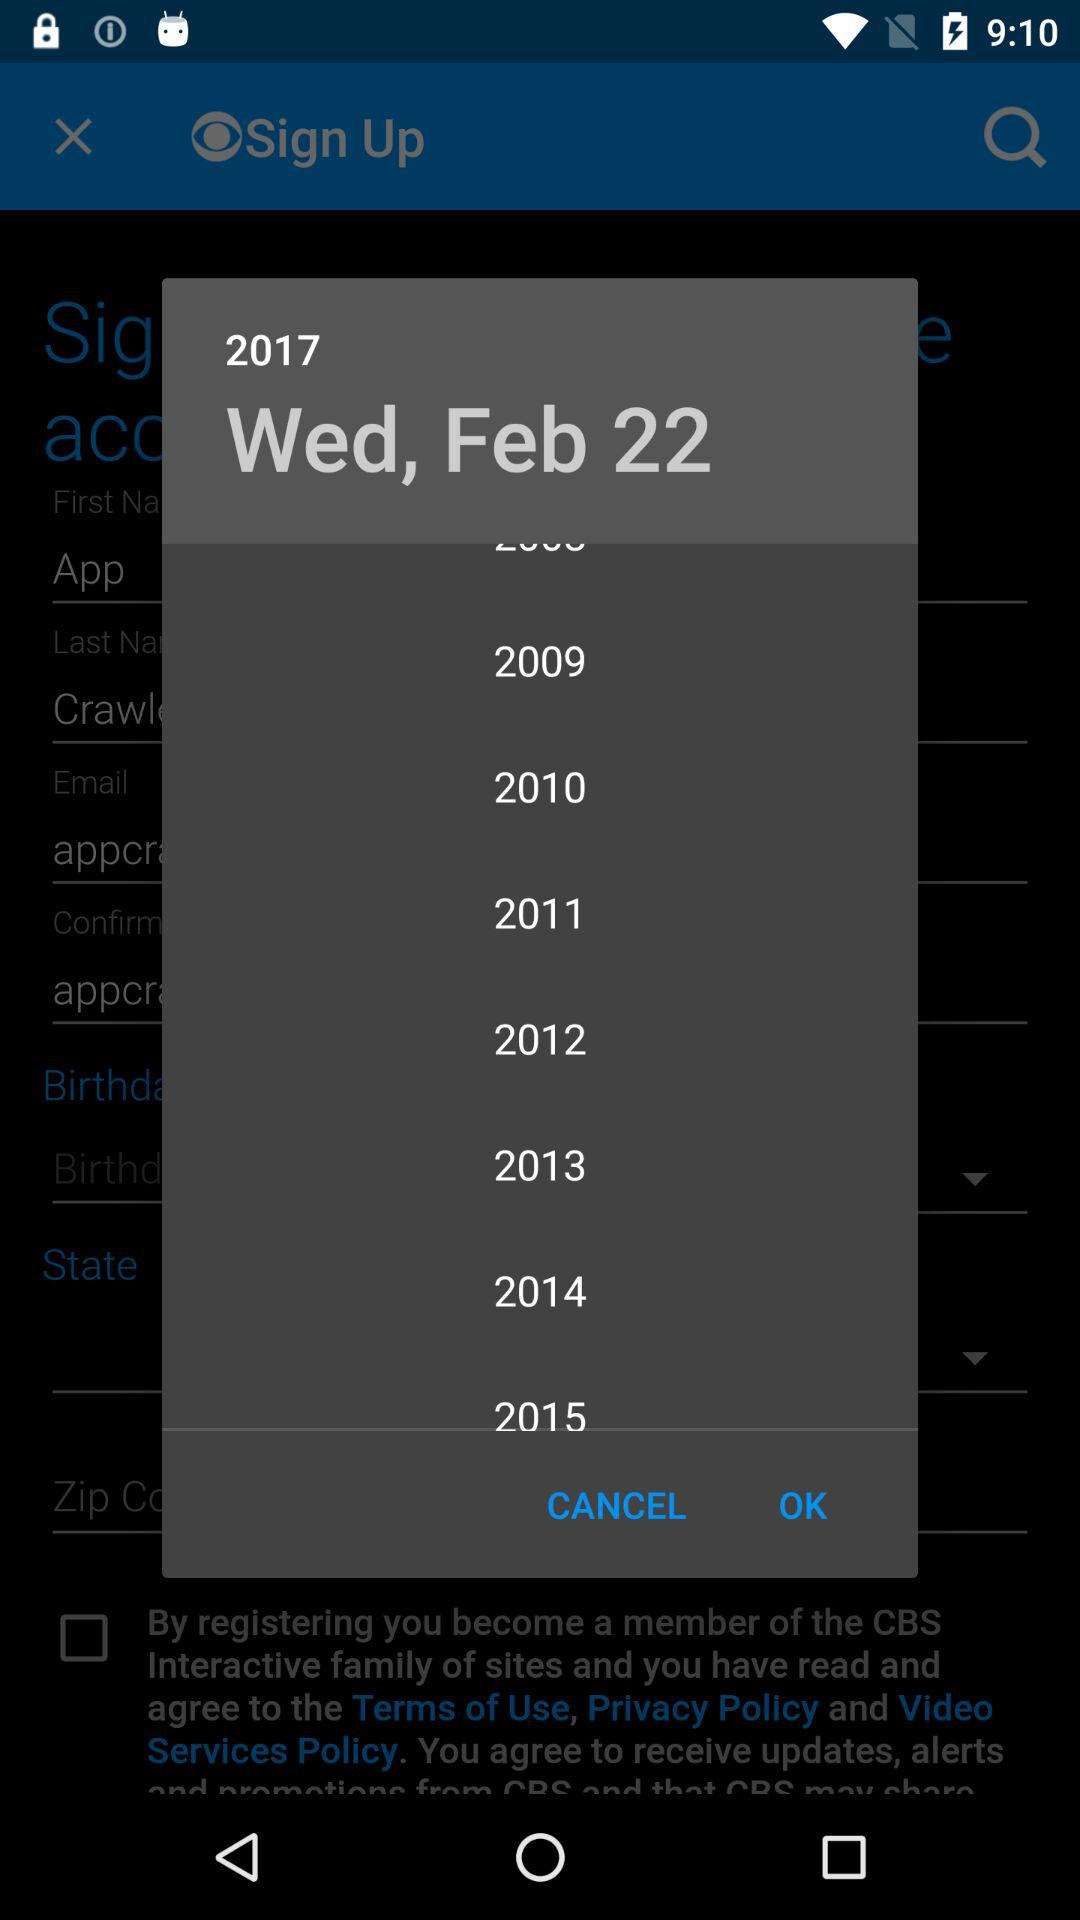What's the selected date? The selected date is Wednesday, February 22, 2017. 